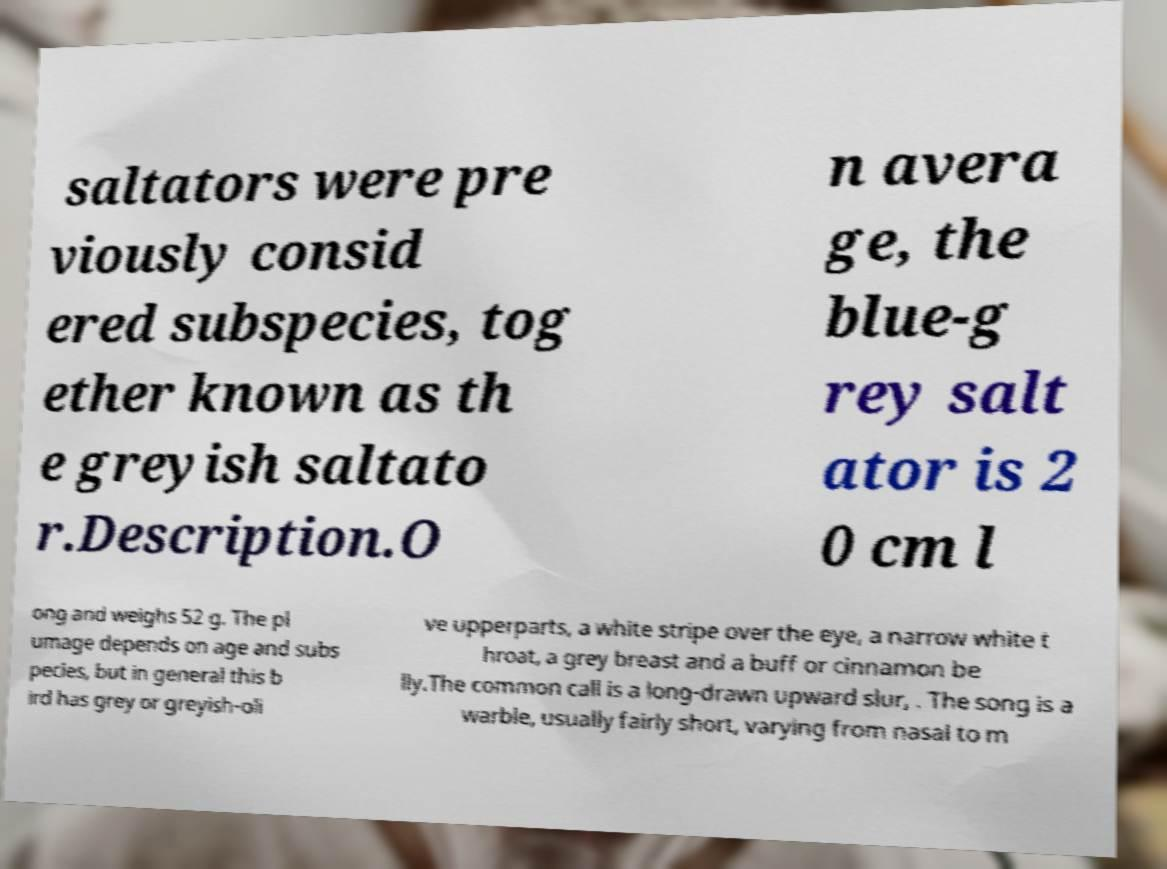Could you assist in decoding the text presented in this image and type it out clearly? saltators were pre viously consid ered subspecies, tog ether known as th e greyish saltato r.Description.O n avera ge, the blue-g rey salt ator is 2 0 cm l ong and weighs 52 g. The pl umage depends on age and subs pecies, but in general this b ird has grey or greyish-oli ve upperparts, a white stripe over the eye, a narrow white t hroat, a grey breast and a buff or cinnamon be lly.The common call is a long-drawn upward slur, . The song is a warble, usually fairly short, varying from nasal to m 